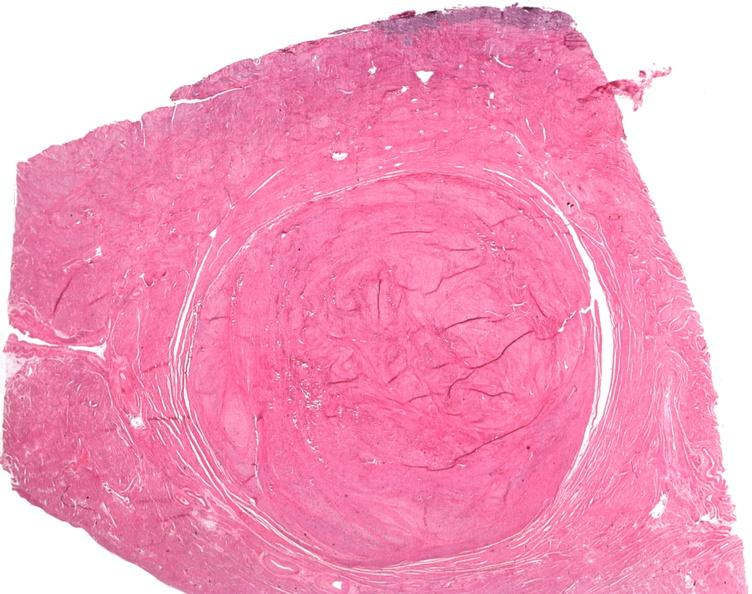what does this image show?
Answer the question using a single word or phrase. Uterus 